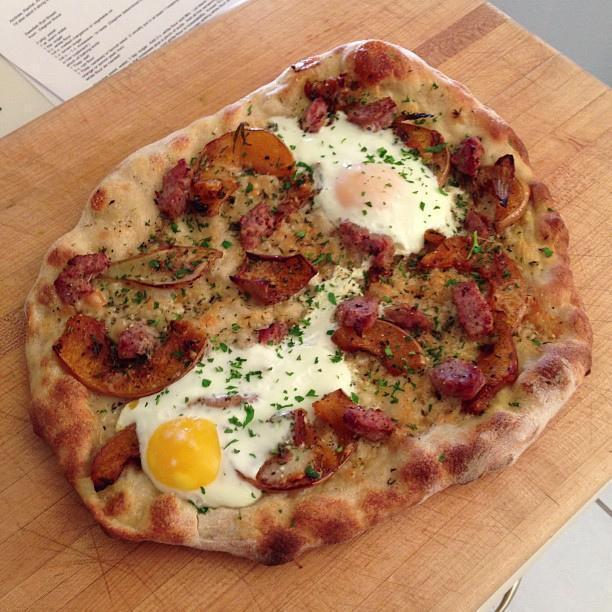How many slices of oranges it there?
Give a very brief answer. 0. 